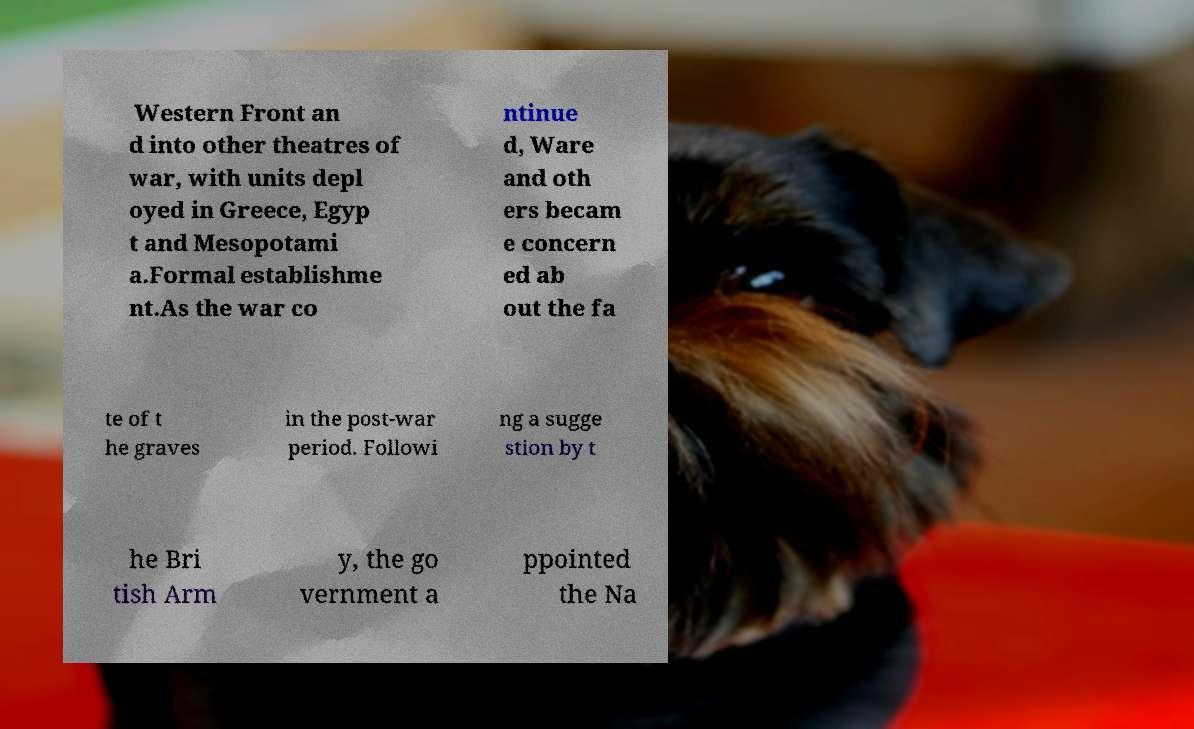Could you assist in decoding the text presented in this image and type it out clearly? Western Front an d into other theatres of war, with units depl oyed in Greece, Egyp t and Mesopotami a.Formal establishme nt.As the war co ntinue d, Ware and oth ers becam e concern ed ab out the fa te of t he graves in the post-war period. Followi ng a sugge stion by t he Bri tish Arm y, the go vernment a ppointed the Na 